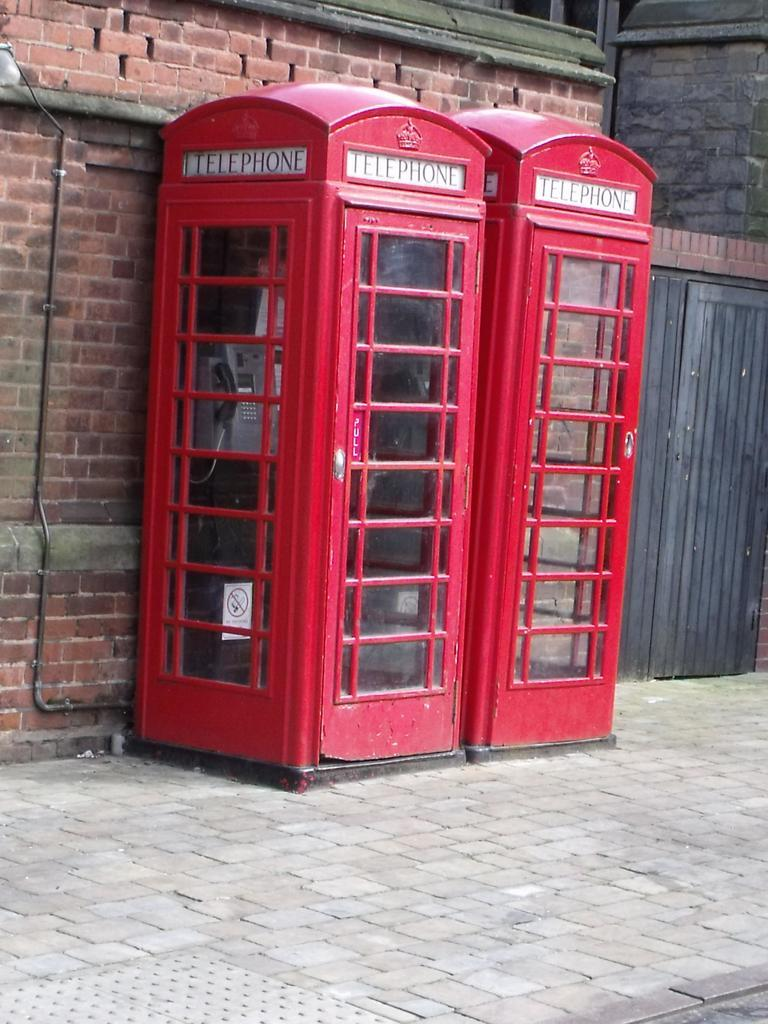<image>
Share a concise interpretation of the image provided. Two red Telephone booths are against a brick wall. 